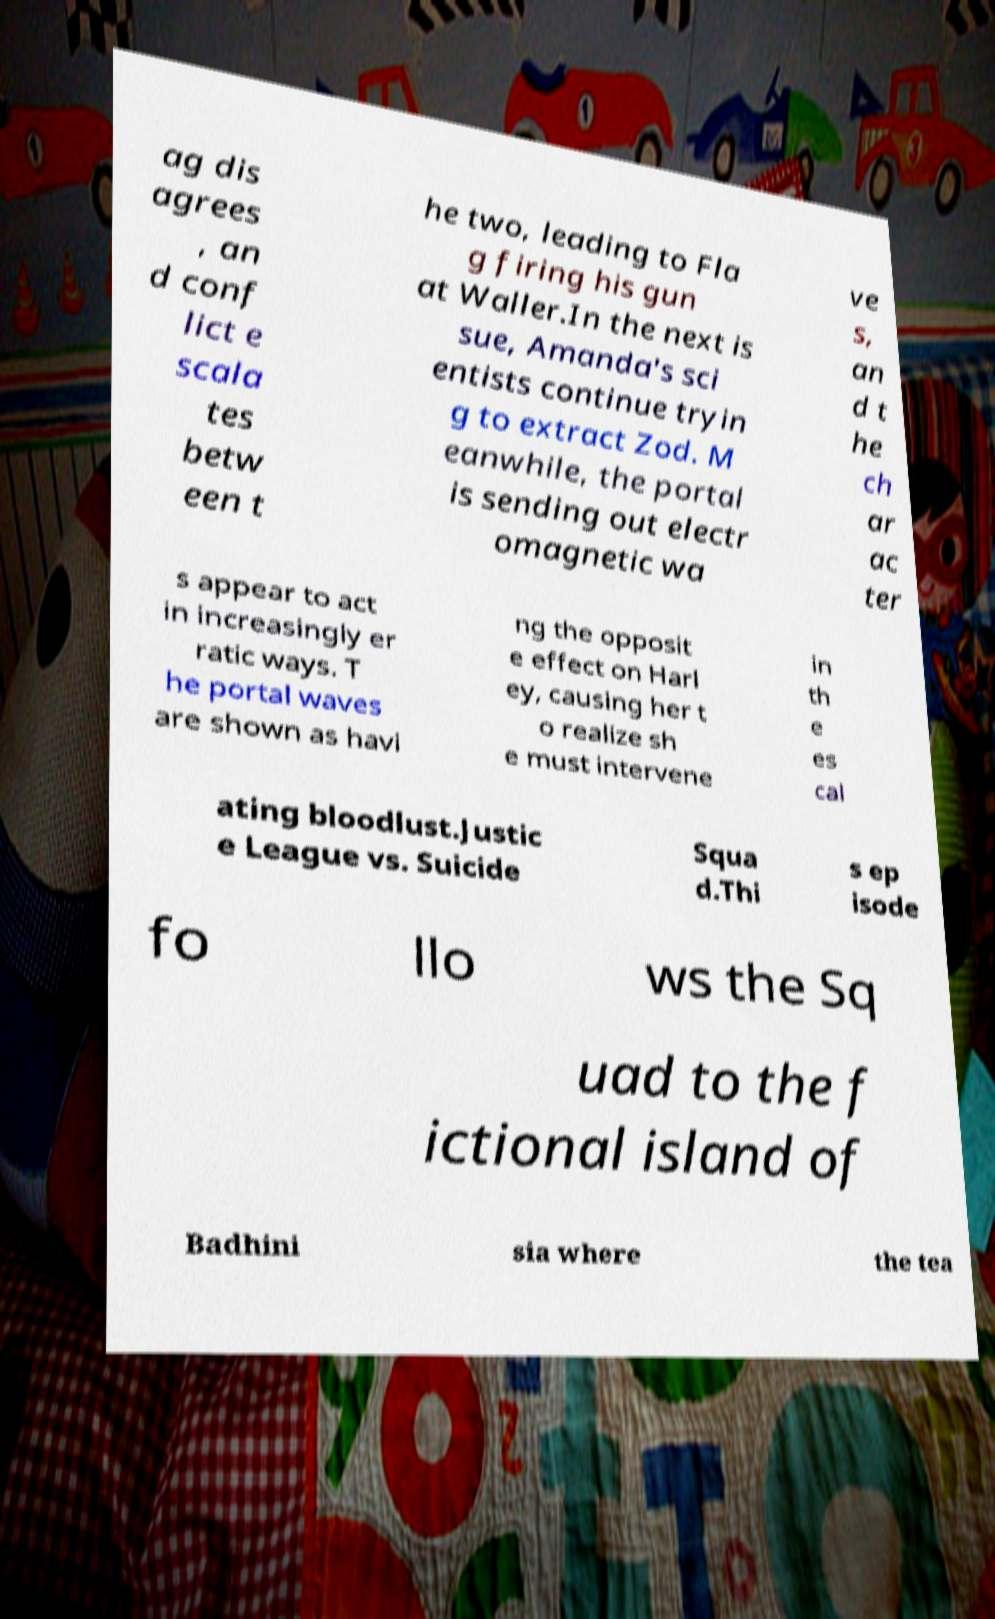I need the written content from this picture converted into text. Can you do that? ag dis agrees , an d conf lict e scala tes betw een t he two, leading to Fla g firing his gun at Waller.In the next is sue, Amanda's sci entists continue tryin g to extract Zod. M eanwhile, the portal is sending out electr omagnetic wa ve s, an d t he ch ar ac ter s appear to act in increasingly er ratic ways. T he portal waves are shown as havi ng the opposit e effect on Harl ey, causing her t o realize sh e must intervene in th e es cal ating bloodlust.Justic e League vs. Suicide Squa d.Thi s ep isode fo llo ws the Sq uad to the f ictional island of Badhini sia where the tea 